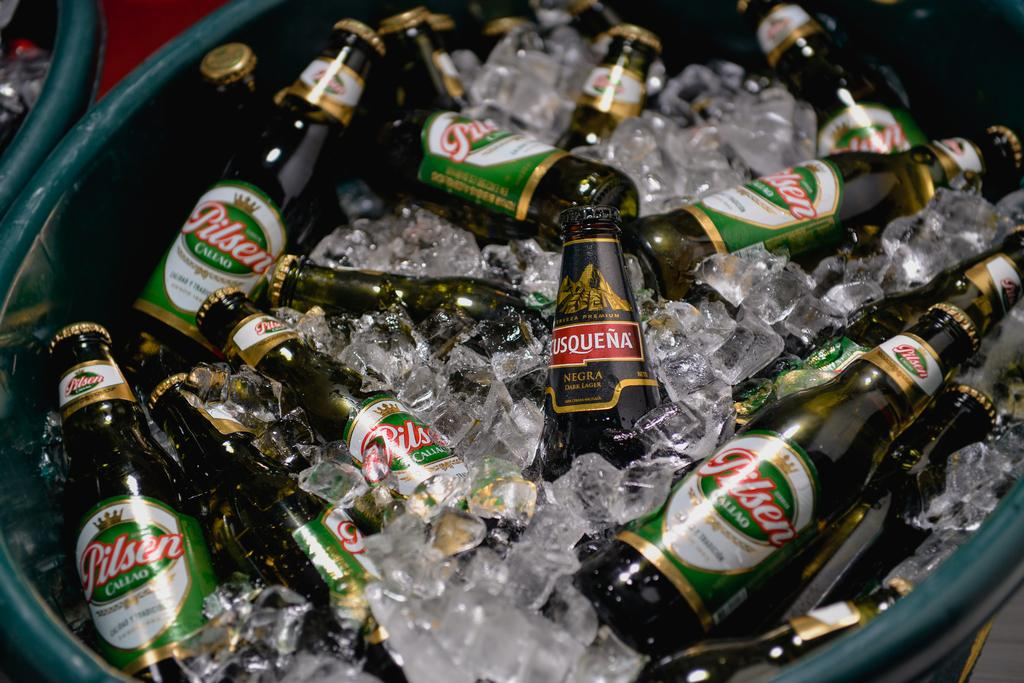<image>
Give a short and clear explanation of the subsequent image. Bucket full of ice as well as bottles of Pilsen. 